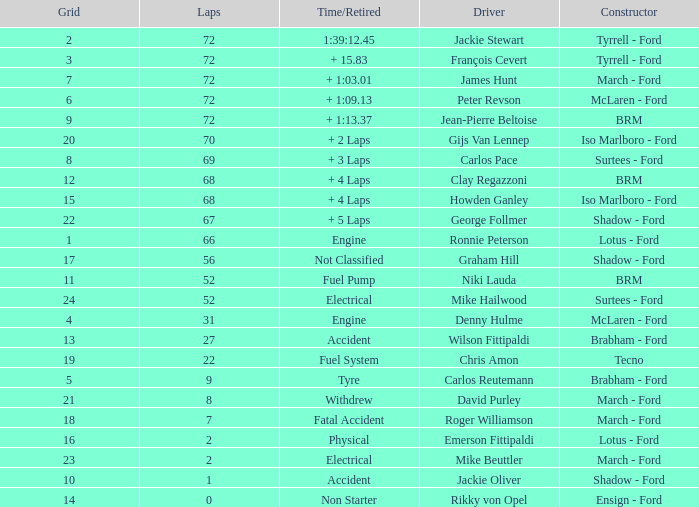What is the top grid that laps less than 66 and a retried engine? 4.0. 